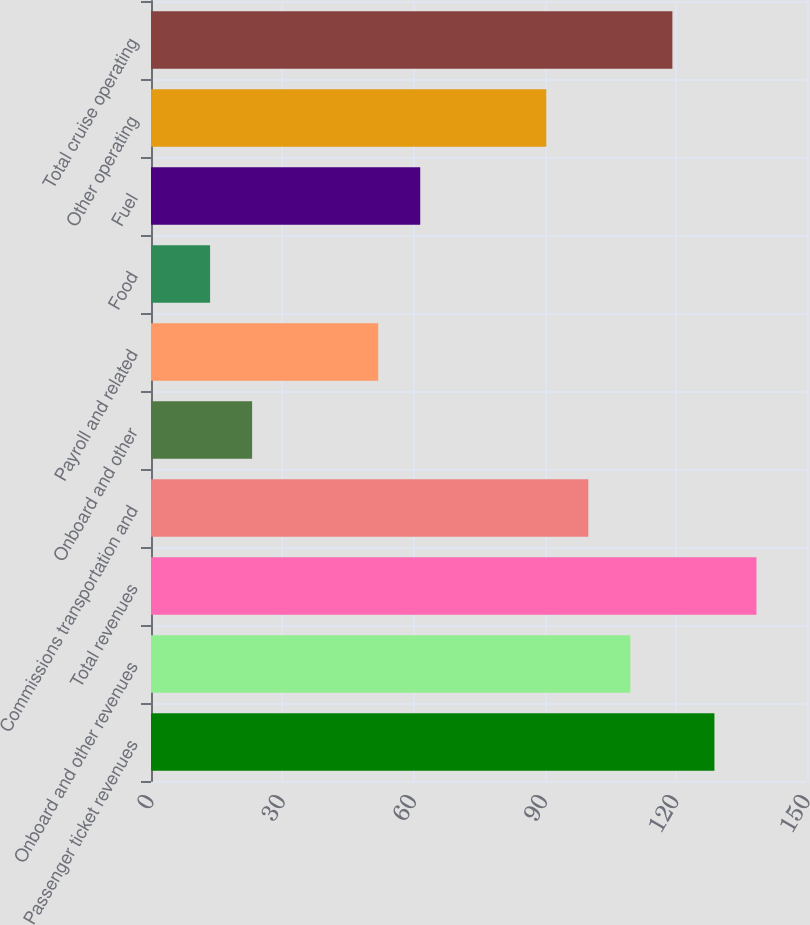<chart> <loc_0><loc_0><loc_500><loc_500><bar_chart><fcel>Passenger ticket revenues<fcel>Onboard and other revenues<fcel>Total revenues<fcel>Commissions transportation and<fcel>Onboard and other<fcel>Payroll and related<fcel>Food<fcel>Fuel<fcel>Other operating<fcel>Total cruise operating<nl><fcel>128.83<fcel>109.61<fcel>138.44<fcel>100<fcel>23.12<fcel>51.95<fcel>13.51<fcel>61.56<fcel>90.39<fcel>119.22<nl></chart> 